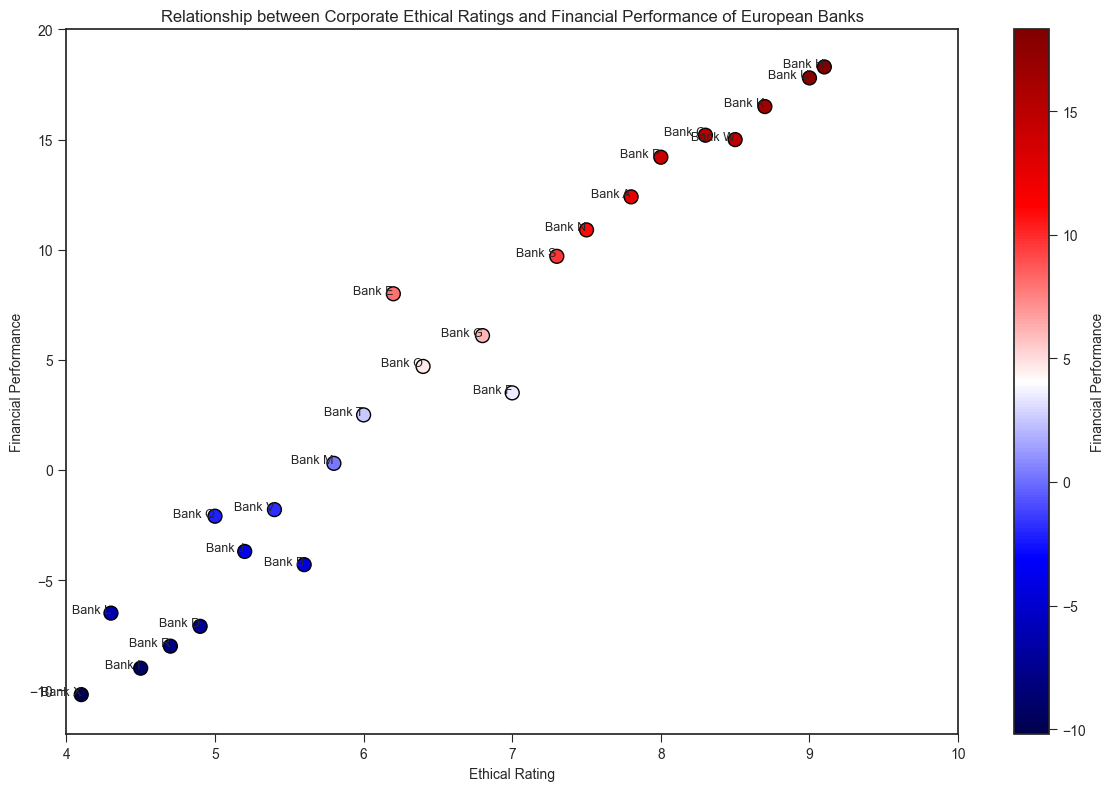Which bank has the highest ethical rating? To find the bank with the highest ethical rating, look at the rightmost point on the x-axis, which corresponds to the highest ethical rating value. The annotation next to this point will indicate the bank's name. In this case, Bank H, with an ethical rating of 9.1, has the highest ethical rating.
Answer: Bank H What is the relationship between ethical rating and financial performance for banks with negative financial performance? Look for the points below the y=0 line to identify banks with negative financial performance. Then, observe their respective positions on the x-axis, which represents their ethical ratings. In general, banks with lower ethical ratings tend to have negative financial performance, but there are exceptions like Bank B with a relatively higher ethical rating of 5.6.
Answer: Banks with lower ethical ratings (e.g., Bank I, Bank X, Bank R) tend to have negative financial performance How many banks have a financial performance greater than 10? Identify the points above the y=10 line, which represent banks with financial performance greater than 10. Count these points. Banks with financial performance over 10 are: Bank A, Bank C, Bank H, Bank K, Bank P, Bank U, and Bank W. This gives a total of 7 banks.
Answer: 7 Which bank with a financial performance less than zero has the highest ethical rating? Look for points below the y=0 line (negative financial performance) and identify the point with the highest x-axis value (ethical rating). Bank B, with a financial performance of -4.3 and an ethical rating of 5.6, has the highest ethical rating among banks with negative financial performance.
Answer: Bank B What is the average ethical rating of banks with financial performance above zero? Identify the points with a y-axis value above 0, then note their corresponding ethical ratings. Banks above zero performance are: A (7.8), C (8.3), E (6.2), F (7.0), G (6.8), H (9.1), K (8.7), N (7.5), O (6.4), P (8.0), S (7.3), T (6.0), and U (9.0). Sum these ratings: 7.8 + 8.3 + 6.2 + 7.0 + 6.8 + 9.1 + 8.7 + 7.5 + 6.4 + 8.0 + 7.3 + 6.0 + 9.0 = 98.1. Divide by the number of banks (13) to get the average: 98.1 / 13 ≈ 7.55.
Answer: 7.55 